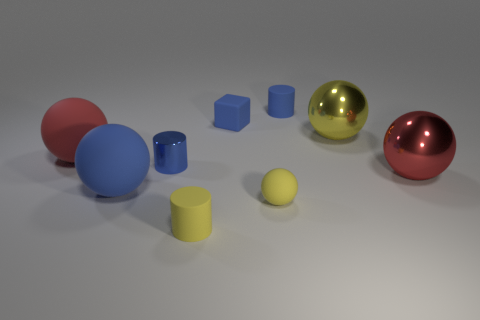Subtract all tiny blue metallic cylinders. How many cylinders are left? 2 Subtract 1 blocks. How many blocks are left? 0 Subtract all blue cylinders. How many cylinders are left? 1 Subtract all cyan cylinders. How many yellow spheres are left? 2 Subtract all cubes. How many objects are left? 8 Subtract all cyan cubes. Subtract all blue spheres. How many cubes are left? 1 Subtract all cyan metallic blocks. Subtract all matte cubes. How many objects are left? 8 Add 4 spheres. How many spheres are left? 9 Add 9 big yellow spheres. How many big yellow spheres exist? 10 Subtract 0 green cylinders. How many objects are left? 9 